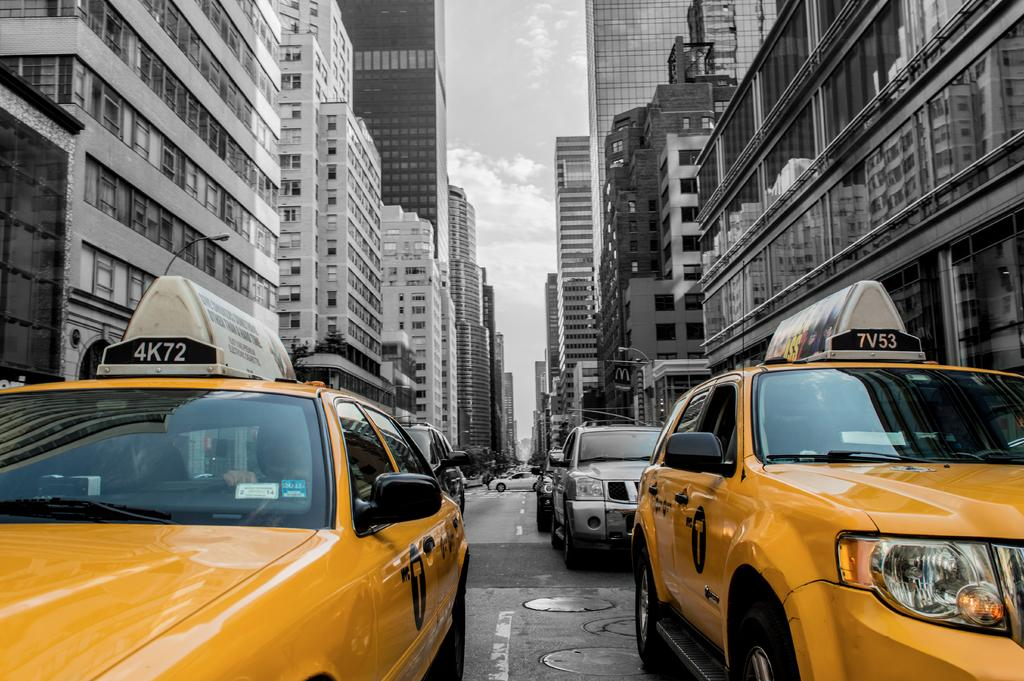<image>
Describe the image concisely. Two yellow taxis are next to each other on a busy city street and the signs on top of the taxis say 4K72 and 7V53 respectively. 